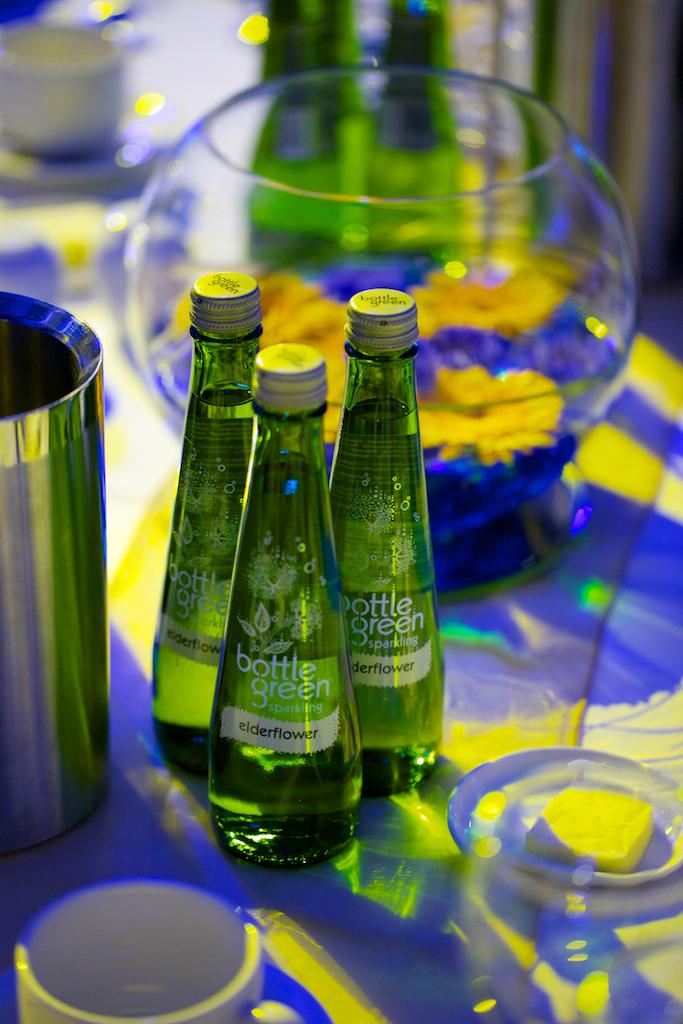How many bottles are visible in the image? There are three bottles in the image. What other objects can be seen in the image? There are glasses and a pot visible in the image. Where are all the objects located? All objects are on a table. Are there any fairies flying around the bottles in the image? No, there are no fairies present in the image. Can you see a kite in the image? No, there is no kite present in the image. 